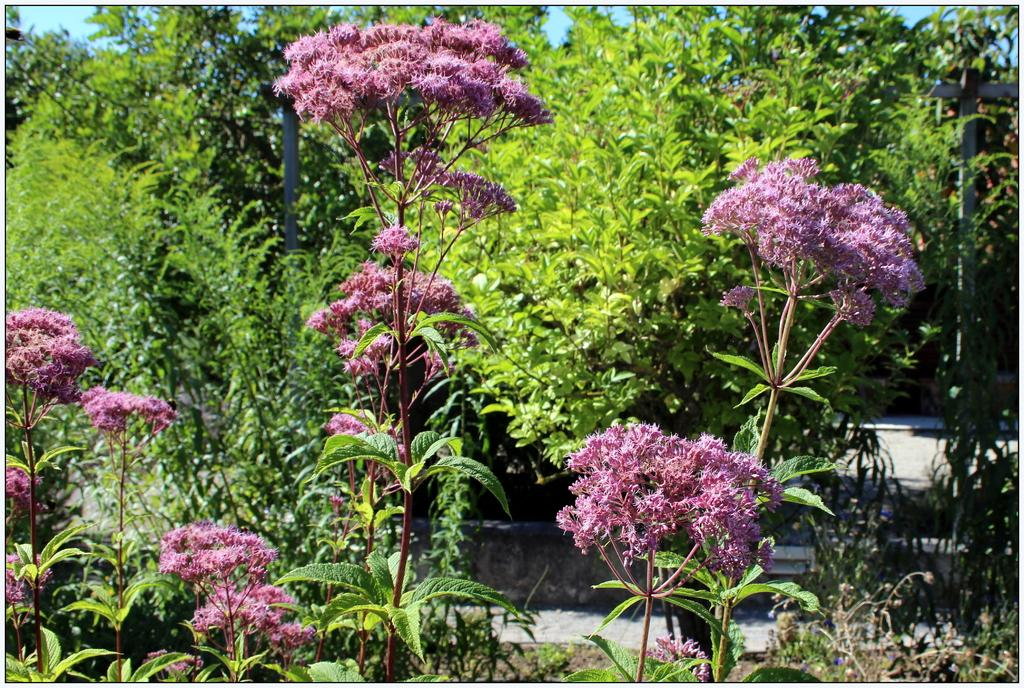What type of vegetation can be seen in the image? There are plants, flowers, and trees in the image. What structures are present in the image? There are poles in the image. What can be seen in the background of the image? The sky is visible in the background of the image. What flavor of ice cream are the plants experiencing in the image? There is no ice cream present in the image, and plants do not experience flavors. 